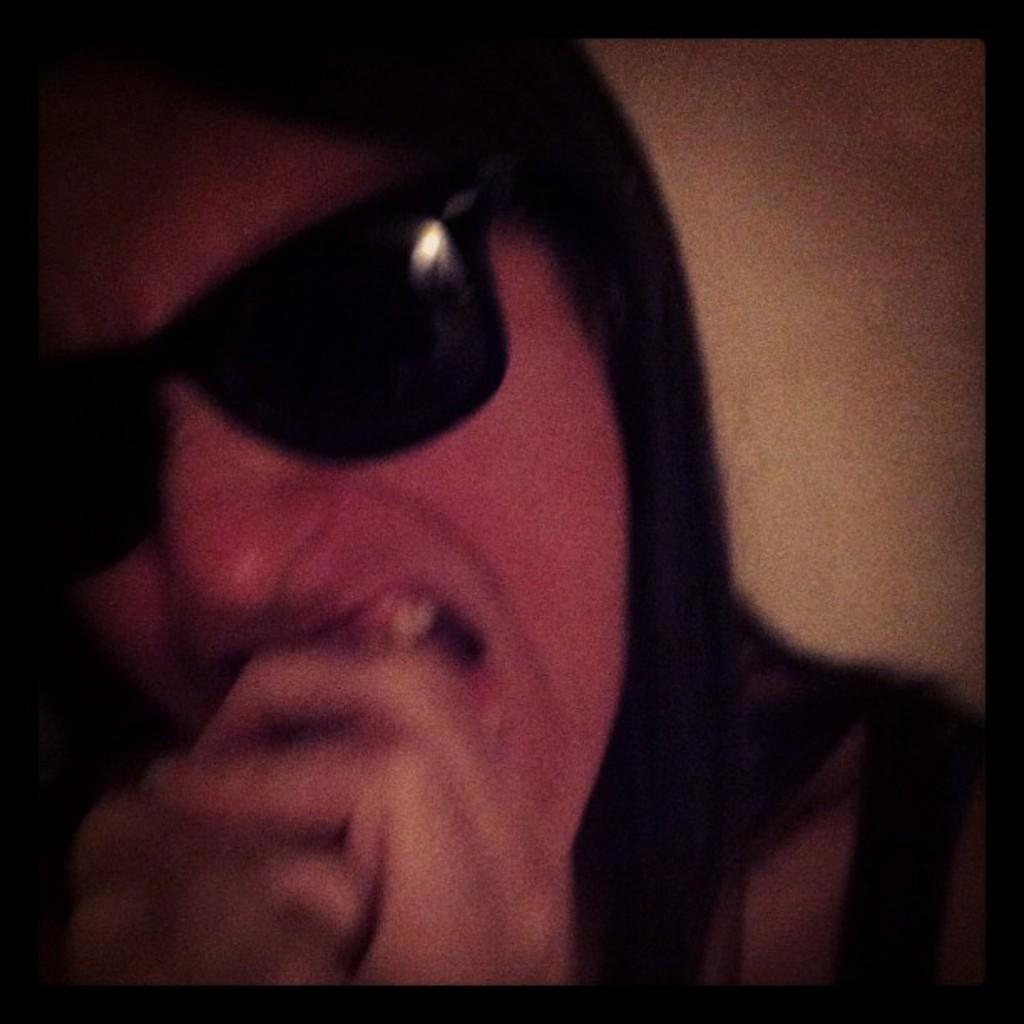Who or what is the main subject in the image? There is a person in the image. What is the person wearing in the image? The person is wearing goggles. What can be seen behind the person in the image? The background of the image appears to be a wall. Can you see any mountains in the background of the image? No, there are no mountains visible in the image; the background appears to be a wall. 